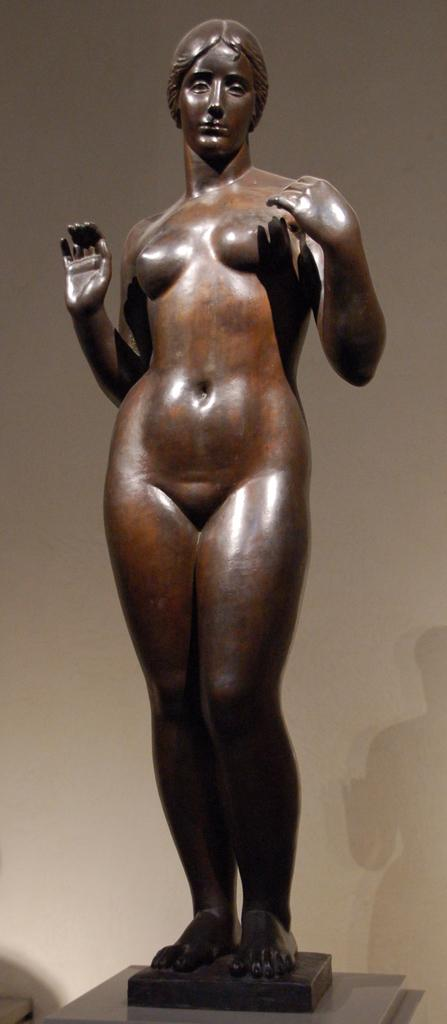What is the main subject in the image? There is a woman sculpture in the image. What can be seen in the background of the image? There is a wall in the background of the image. What else is visible in the image besides the sculpture and the wall? The shadow of the sculpture is visible in the image. What type of hat is the woman sculpture wearing in the image? The woman sculpture is not wearing a hat in the image. What type of animal is attacking the woman sculpture in the image? There is no animal present in the image, nor is there any indication of an attack. 